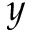<formula> <loc_0><loc_0><loc_500><loc_500>y</formula> 